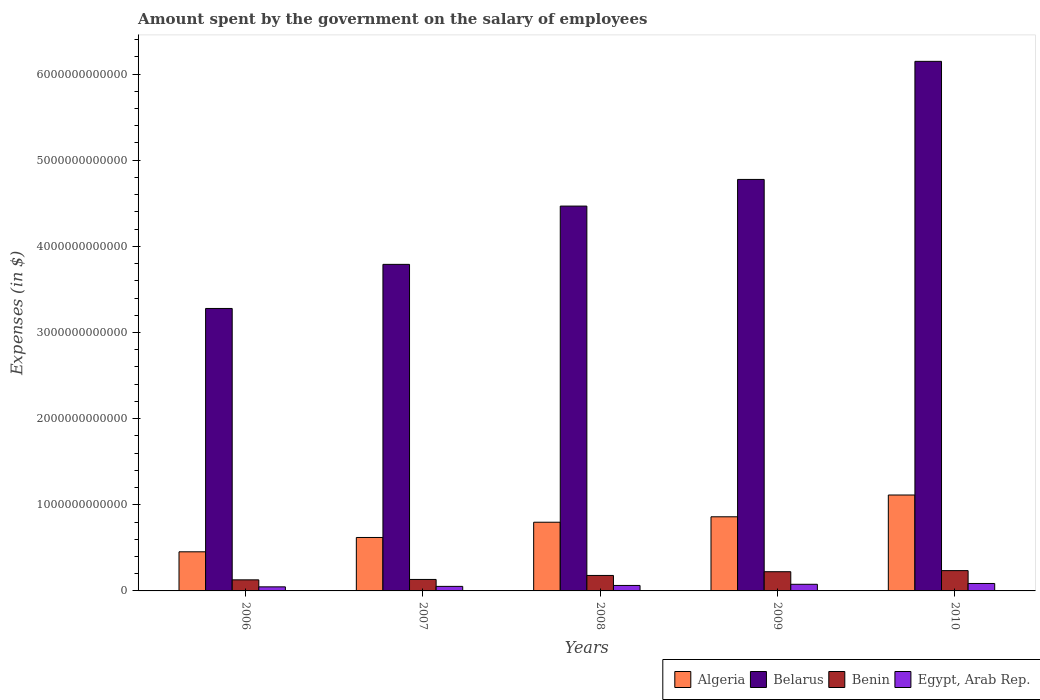How many different coloured bars are there?
Offer a very short reply. 4. How many groups of bars are there?
Keep it short and to the point. 5. Are the number of bars on each tick of the X-axis equal?
Your answer should be compact. Yes. How many bars are there on the 1st tick from the left?
Offer a very short reply. 4. What is the label of the 3rd group of bars from the left?
Provide a short and direct response. 2008. What is the amount spent on the salary of employees by the government in Egypt, Arab Rep. in 2009?
Make the answer very short. 7.70e+1. Across all years, what is the maximum amount spent on the salary of employees by the government in Egypt, Arab Rep.?
Your answer should be very brief. 8.64e+1. Across all years, what is the minimum amount spent on the salary of employees by the government in Egypt, Arab Rep.?
Provide a succinct answer. 4.73e+1. In which year was the amount spent on the salary of employees by the government in Algeria minimum?
Ensure brevity in your answer.  2006. What is the total amount spent on the salary of employees by the government in Egypt, Arab Rep. in the graph?
Give a very brief answer. 3.27e+11. What is the difference between the amount spent on the salary of employees by the government in Belarus in 2007 and that in 2009?
Your answer should be very brief. -9.86e+11. What is the difference between the amount spent on the salary of employees by the government in Egypt, Arab Rep. in 2009 and the amount spent on the salary of employees by the government in Benin in 2006?
Your answer should be very brief. -5.15e+1. What is the average amount spent on the salary of employees by the government in Algeria per year?
Make the answer very short. 7.69e+11. In the year 2006, what is the difference between the amount spent on the salary of employees by the government in Benin and amount spent on the salary of employees by the government in Belarus?
Keep it short and to the point. -3.15e+12. What is the ratio of the amount spent on the salary of employees by the government in Benin in 2008 to that in 2009?
Make the answer very short. 0.81. Is the difference between the amount spent on the salary of employees by the government in Benin in 2007 and 2009 greater than the difference between the amount spent on the salary of employees by the government in Belarus in 2007 and 2009?
Give a very brief answer. Yes. What is the difference between the highest and the second highest amount spent on the salary of employees by the government in Belarus?
Your answer should be very brief. 1.37e+12. What is the difference between the highest and the lowest amount spent on the salary of employees by the government in Algeria?
Your answer should be compact. 6.59e+11. Is it the case that in every year, the sum of the amount spent on the salary of employees by the government in Egypt, Arab Rep. and amount spent on the salary of employees by the government in Algeria is greater than the sum of amount spent on the salary of employees by the government in Benin and amount spent on the salary of employees by the government in Belarus?
Ensure brevity in your answer.  No. What does the 2nd bar from the left in 2008 represents?
Keep it short and to the point. Belarus. What does the 1st bar from the right in 2006 represents?
Offer a terse response. Egypt, Arab Rep. How many bars are there?
Offer a very short reply. 20. Are all the bars in the graph horizontal?
Your answer should be compact. No. What is the difference between two consecutive major ticks on the Y-axis?
Ensure brevity in your answer.  1.00e+12. Are the values on the major ticks of Y-axis written in scientific E-notation?
Offer a terse response. No. What is the title of the graph?
Make the answer very short. Amount spent by the government on the salary of employees. Does "Luxembourg" appear as one of the legend labels in the graph?
Your answer should be compact. No. What is the label or title of the Y-axis?
Give a very brief answer. Expenses (in $). What is the Expenses (in $) in Algeria in 2006?
Your answer should be compact. 4.54e+11. What is the Expenses (in $) in Belarus in 2006?
Keep it short and to the point. 3.28e+12. What is the Expenses (in $) of Benin in 2006?
Provide a succinct answer. 1.28e+11. What is the Expenses (in $) in Egypt, Arab Rep. in 2006?
Your answer should be compact. 4.73e+1. What is the Expenses (in $) in Algeria in 2007?
Make the answer very short. 6.20e+11. What is the Expenses (in $) of Belarus in 2007?
Your answer should be very brief. 3.79e+12. What is the Expenses (in $) of Benin in 2007?
Offer a terse response. 1.33e+11. What is the Expenses (in $) of Egypt, Arab Rep. in 2007?
Make the answer very short. 5.27e+1. What is the Expenses (in $) in Algeria in 2008?
Your answer should be very brief. 7.97e+11. What is the Expenses (in $) of Belarus in 2008?
Ensure brevity in your answer.  4.47e+12. What is the Expenses (in $) of Benin in 2008?
Ensure brevity in your answer.  1.80e+11. What is the Expenses (in $) in Egypt, Arab Rep. in 2008?
Ensure brevity in your answer.  6.35e+1. What is the Expenses (in $) in Algeria in 2009?
Offer a terse response. 8.61e+11. What is the Expenses (in $) of Belarus in 2009?
Provide a succinct answer. 4.78e+12. What is the Expenses (in $) in Benin in 2009?
Your answer should be very brief. 2.23e+11. What is the Expenses (in $) in Egypt, Arab Rep. in 2009?
Keep it short and to the point. 7.70e+1. What is the Expenses (in $) in Algeria in 2010?
Give a very brief answer. 1.11e+12. What is the Expenses (in $) in Belarus in 2010?
Keep it short and to the point. 6.15e+12. What is the Expenses (in $) in Benin in 2010?
Make the answer very short. 2.36e+11. What is the Expenses (in $) in Egypt, Arab Rep. in 2010?
Offer a terse response. 8.64e+1. Across all years, what is the maximum Expenses (in $) in Algeria?
Make the answer very short. 1.11e+12. Across all years, what is the maximum Expenses (in $) in Belarus?
Keep it short and to the point. 6.15e+12. Across all years, what is the maximum Expenses (in $) in Benin?
Your answer should be compact. 2.36e+11. Across all years, what is the maximum Expenses (in $) of Egypt, Arab Rep.?
Provide a short and direct response. 8.64e+1. Across all years, what is the minimum Expenses (in $) of Algeria?
Provide a succinct answer. 4.54e+11. Across all years, what is the minimum Expenses (in $) in Belarus?
Offer a terse response. 3.28e+12. Across all years, what is the minimum Expenses (in $) in Benin?
Make the answer very short. 1.28e+11. Across all years, what is the minimum Expenses (in $) in Egypt, Arab Rep.?
Make the answer very short. 4.73e+1. What is the total Expenses (in $) in Algeria in the graph?
Give a very brief answer. 3.85e+12. What is the total Expenses (in $) of Belarus in the graph?
Give a very brief answer. 2.25e+13. What is the total Expenses (in $) of Benin in the graph?
Offer a very short reply. 9.00e+11. What is the total Expenses (in $) of Egypt, Arab Rep. in the graph?
Your response must be concise. 3.27e+11. What is the difference between the Expenses (in $) in Algeria in 2006 and that in 2007?
Provide a succinct answer. -1.66e+11. What is the difference between the Expenses (in $) of Belarus in 2006 and that in 2007?
Your answer should be very brief. -5.12e+11. What is the difference between the Expenses (in $) of Benin in 2006 and that in 2007?
Give a very brief answer. -4.72e+09. What is the difference between the Expenses (in $) of Egypt, Arab Rep. in 2006 and that in 2007?
Provide a short and direct response. -5.49e+09. What is the difference between the Expenses (in $) of Algeria in 2006 and that in 2008?
Your response must be concise. -3.43e+11. What is the difference between the Expenses (in $) of Belarus in 2006 and that in 2008?
Make the answer very short. -1.19e+12. What is the difference between the Expenses (in $) in Benin in 2006 and that in 2008?
Keep it short and to the point. -5.12e+1. What is the difference between the Expenses (in $) of Egypt, Arab Rep. in 2006 and that in 2008?
Provide a short and direct response. -1.63e+1. What is the difference between the Expenses (in $) in Algeria in 2006 and that in 2009?
Offer a terse response. -4.06e+11. What is the difference between the Expenses (in $) in Belarus in 2006 and that in 2009?
Offer a terse response. -1.50e+12. What is the difference between the Expenses (in $) of Benin in 2006 and that in 2009?
Provide a succinct answer. -9.44e+1. What is the difference between the Expenses (in $) in Egypt, Arab Rep. in 2006 and that in 2009?
Your response must be concise. -2.97e+1. What is the difference between the Expenses (in $) in Algeria in 2006 and that in 2010?
Ensure brevity in your answer.  -6.59e+11. What is the difference between the Expenses (in $) in Belarus in 2006 and that in 2010?
Offer a very short reply. -2.87e+12. What is the difference between the Expenses (in $) of Benin in 2006 and that in 2010?
Keep it short and to the point. -1.07e+11. What is the difference between the Expenses (in $) in Egypt, Arab Rep. in 2006 and that in 2010?
Your answer should be very brief. -3.91e+1. What is the difference between the Expenses (in $) in Algeria in 2007 and that in 2008?
Ensure brevity in your answer.  -1.77e+11. What is the difference between the Expenses (in $) of Belarus in 2007 and that in 2008?
Offer a terse response. -6.76e+11. What is the difference between the Expenses (in $) in Benin in 2007 and that in 2008?
Provide a short and direct response. -4.65e+1. What is the difference between the Expenses (in $) of Egypt, Arab Rep. in 2007 and that in 2008?
Offer a terse response. -1.08e+1. What is the difference between the Expenses (in $) in Algeria in 2007 and that in 2009?
Keep it short and to the point. -2.40e+11. What is the difference between the Expenses (in $) in Belarus in 2007 and that in 2009?
Give a very brief answer. -9.86e+11. What is the difference between the Expenses (in $) of Benin in 2007 and that in 2009?
Keep it short and to the point. -8.97e+1. What is the difference between the Expenses (in $) of Egypt, Arab Rep. in 2007 and that in 2009?
Ensure brevity in your answer.  -2.42e+1. What is the difference between the Expenses (in $) of Algeria in 2007 and that in 2010?
Provide a short and direct response. -4.93e+11. What is the difference between the Expenses (in $) in Belarus in 2007 and that in 2010?
Keep it short and to the point. -2.36e+12. What is the difference between the Expenses (in $) of Benin in 2007 and that in 2010?
Your response must be concise. -1.02e+11. What is the difference between the Expenses (in $) in Egypt, Arab Rep. in 2007 and that in 2010?
Your answer should be compact. -3.36e+1. What is the difference between the Expenses (in $) in Algeria in 2008 and that in 2009?
Offer a terse response. -6.32e+1. What is the difference between the Expenses (in $) in Belarus in 2008 and that in 2009?
Provide a succinct answer. -3.10e+11. What is the difference between the Expenses (in $) in Benin in 2008 and that in 2009?
Your response must be concise. -4.32e+1. What is the difference between the Expenses (in $) in Egypt, Arab Rep. in 2008 and that in 2009?
Provide a short and direct response. -1.34e+1. What is the difference between the Expenses (in $) of Algeria in 2008 and that in 2010?
Offer a terse response. -3.16e+11. What is the difference between the Expenses (in $) in Belarus in 2008 and that in 2010?
Provide a short and direct response. -1.68e+12. What is the difference between the Expenses (in $) of Benin in 2008 and that in 2010?
Your response must be concise. -5.59e+1. What is the difference between the Expenses (in $) of Egypt, Arab Rep. in 2008 and that in 2010?
Provide a succinct answer. -2.28e+1. What is the difference between the Expenses (in $) of Algeria in 2009 and that in 2010?
Keep it short and to the point. -2.53e+11. What is the difference between the Expenses (in $) of Belarus in 2009 and that in 2010?
Make the answer very short. -1.37e+12. What is the difference between the Expenses (in $) in Benin in 2009 and that in 2010?
Make the answer very short. -1.27e+1. What is the difference between the Expenses (in $) in Egypt, Arab Rep. in 2009 and that in 2010?
Offer a very short reply. -9.41e+09. What is the difference between the Expenses (in $) of Algeria in 2006 and the Expenses (in $) of Belarus in 2007?
Your response must be concise. -3.34e+12. What is the difference between the Expenses (in $) in Algeria in 2006 and the Expenses (in $) in Benin in 2007?
Provide a succinct answer. 3.21e+11. What is the difference between the Expenses (in $) of Algeria in 2006 and the Expenses (in $) of Egypt, Arab Rep. in 2007?
Keep it short and to the point. 4.01e+11. What is the difference between the Expenses (in $) in Belarus in 2006 and the Expenses (in $) in Benin in 2007?
Offer a very short reply. 3.15e+12. What is the difference between the Expenses (in $) of Belarus in 2006 and the Expenses (in $) of Egypt, Arab Rep. in 2007?
Ensure brevity in your answer.  3.23e+12. What is the difference between the Expenses (in $) of Benin in 2006 and the Expenses (in $) of Egypt, Arab Rep. in 2007?
Give a very brief answer. 7.57e+1. What is the difference between the Expenses (in $) in Algeria in 2006 and the Expenses (in $) in Belarus in 2008?
Keep it short and to the point. -4.01e+12. What is the difference between the Expenses (in $) of Algeria in 2006 and the Expenses (in $) of Benin in 2008?
Your answer should be very brief. 2.74e+11. What is the difference between the Expenses (in $) of Algeria in 2006 and the Expenses (in $) of Egypt, Arab Rep. in 2008?
Provide a short and direct response. 3.91e+11. What is the difference between the Expenses (in $) of Belarus in 2006 and the Expenses (in $) of Benin in 2008?
Your answer should be very brief. 3.10e+12. What is the difference between the Expenses (in $) of Belarus in 2006 and the Expenses (in $) of Egypt, Arab Rep. in 2008?
Make the answer very short. 3.22e+12. What is the difference between the Expenses (in $) in Benin in 2006 and the Expenses (in $) in Egypt, Arab Rep. in 2008?
Offer a terse response. 6.49e+1. What is the difference between the Expenses (in $) in Algeria in 2006 and the Expenses (in $) in Belarus in 2009?
Keep it short and to the point. -4.32e+12. What is the difference between the Expenses (in $) in Algeria in 2006 and the Expenses (in $) in Benin in 2009?
Offer a terse response. 2.31e+11. What is the difference between the Expenses (in $) of Algeria in 2006 and the Expenses (in $) of Egypt, Arab Rep. in 2009?
Provide a short and direct response. 3.77e+11. What is the difference between the Expenses (in $) in Belarus in 2006 and the Expenses (in $) in Benin in 2009?
Your answer should be very brief. 3.06e+12. What is the difference between the Expenses (in $) in Belarus in 2006 and the Expenses (in $) in Egypt, Arab Rep. in 2009?
Provide a succinct answer. 3.20e+12. What is the difference between the Expenses (in $) in Benin in 2006 and the Expenses (in $) in Egypt, Arab Rep. in 2009?
Provide a short and direct response. 5.15e+1. What is the difference between the Expenses (in $) in Algeria in 2006 and the Expenses (in $) in Belarus in 2010?
Make the answer very short. -5.69e+12. What is the difference between the Expenses (in $) in Algeria in 2006 and the Expenses (in $) in Benin in 2010?
Your answer should be compact. 2.18e+11. What is the difference between the Expenses (in $) in Algeria in 2006 and the Expenses (in $) in Egypt, Arab Rep. in 2010?
Keep it short and to the point. 3.68e+11. What is the difference between the Expenses (in $) of Belarus in 2006 and the Expenses (in $) of Benin in 2010?
Offer a very short reply. 3.04e+12. What is the difference between the Expenses (in $) in Belarus in 2006 and the Expenses (in $) in Egypt, Arab Rep. in 2010?
Your response must be concise. 3.19e+12. What is the difference between the Expenses (in $) in Benin in 2006 and the Expenses (in $) in Egypt, Arab Rep. in 2010?
Offer a very short reply. 4.21e+1. What is the difference between the Expenses (in $) in Algeria in 2007 and the Expenses (in $) in Belarus in 2008?
Make the answer very short. -3.85e+12. What is the difference between the Expenses (in $) in Algeria in 2007 and the Expenses (in $) in Benin in 2008?
Keep it short and to the point. 4.41e+11. What is the difference between the Expenses (in $) of Algeria in 2007 and the Expenses (in $) of Egypt, Arab Rep. in 2008?
Provide a short and direct response. 5.57e+11. What is the difference between the Expenses (in $) of Belarus in 2007 and the Expenses (in $) of Benin in 2008?
Offer a very short reply. 3.61e+12. What is the difference between the Expenses (in $) of Belarus in 2007 and the Expenses (in $) of Egypt, Arab Rep. in 2008?
Your answer should be compact. 3.73e+12. What is the difference between the Expenses (in $) in Benin in 2007 and the Expenses (in $) in Egypt, Arab Rep. in 2008?
Keep it short and to the point. 6.97e+1. What is the difference between the Expenses (in $) in Algeria in 2007 and the Expenses (in $) in Belarus in 2009?
Offer a terse response. -4.16e+12. What is the difference between the Expenses (in $) in Algeria in 2007 and the Expenses (in $) in Benin in 2009?
Your answer should be compact. 3.97e+11. What is the difference between the Expenses (in $) of Algeria in 2007 and the Expenses (in $) of Egypt, Arab Rep. in 2009?
Make the answer very short. 5.43e+11. What is the difference between the Expenses (in $) in Belarus in 2007 and the Expenses (in $) in Benin in 2009?
Your response must be concise. 3.57e+12. What is the difference between the Expenses (in $) of Belarus in 2007 and the Expenses (in $) of Egypt, Arab Rep. in 2009?
Ensure brevity in your answer.  3.71e+12. What is the difference between the Expenses (in $) in Benin in 2007 and the Expenses (in $) in Egypt, Arab Rep. in 2009?
Keep it short and to the point. 5.62e+1. What is the difference between the Expenses (in $) in Algeria in 2007 and the Expenses (in $) in Belarus in 2010?
Provide a succinct answer. -5.53e+12. What is the difference between the Expenses (in $) in Algeria in 2007 and the Expenses (in $) in Benin in 2010?
Make the answer very short. 3.85e+11. What is the difference between the Expenses (in $) of Algeria in 2007 and the Expenses (in $) of Egypt, Arab Rep. in 2010?
Provide a succinct answer. 5.34e+11. What is the difference between the Expenses (in $) in Belarus in 2007 and the Expenses (in $) in Benin in 2010?
Your answer should be very brief. 3.55e+12. What is the difference between the Expenses (in $) of Belarus in 2007 and the Expenses (in $) of Egypt, Arab Rep. in 2010?
Provide a short and direct response. 3.70e+12. What is the difference between the Expenses (in $) of Benin in 2007 and the Expenses (in $) of Egypt, Arab Rep. in 2010?
Offer a terse response. 4.68e+1. What is the difference between the Expenses (in $) in Algeria in 2008 and the Expenses (in $) in Belarus in 2009?
Make the answer very short. -3.98e+12. What is the difference between the Expenses (in $) in Algeria in 2008 and the Expenses (in $) in Benin in 2009?
Make the answer very short. 5.74e+11. What is the difference between the Expenses (in $) of Algeria in 2008 and the Expenses (in $) of Egypt, Arab Rep. in 2009?
Make the answer very short. 7.20e+11. What is the difference between the Expenses (in $) of Belarus in 2008 and the Expenses (in $) of Benin in 2009?
Your response must be concise. 4.24e+12. What is the difference between the Expenses (in $) of Belarus in 2008 and the Expenses (in $) of Egypt, Arab Rep. in 2009?
Ensure brevity in your answer.  4.39e+12. What is the difference between the Expenses (in $) of Benin in 2008 and the Expenses (in $) of Egypt, Arab Rep. in 2009?
Your response must be concise. 1.03e+11. What is the difference between the Expenses (in $) of Algeria in 2008 and the Expenses (in $) of Belarus in 2010?
Your answer should be very brief. -5.35e+12. What is the difference between the Expenses (in $) in Algeria in 2008 and the Expenses (in $) in Benin in 2010?
Offer a terse response. 5.62e+11. What is the difference between the Expenses (in $) in Algeria in 2008 and the Expenses (in $) in Egypt, Arab Rep. in 2010?
Ensure brevity in your answer.  7.11e+11. What is the difference between the Expenses (in $) of Belarus in 2008 and the Expenses (in $) of Benin in 2010?
Your answer should be compact. 4.23e+12. What is the difference between the Expenses (in $) of Belarus in 2008 and the Expenses (in $) of Egypt, Arab Rep. in 2010?
Make the answer very short. 4.38e+12. What is the difference between the Expenses (in $) of Benin in 2008 and the Expenses (in $) of Egypt, Arab Rep. in 2010?
Offer a terse response. 9.33e+1. What is the difference between the Expenses (in $) of Algeria in 2009 and the Expenses (in $) of Belarus in 2010?
Make the answer very short. -5.29e+12. What is the difference between the Expenses (in $) in Algeria in 2009 and the Expenses (in $) in Benin in 2010?
Offer a terse response. 6.25e+11. What is the difference between the Expenses (in $) of Algeria in 2009 and the Expenses (in $) of Egypt, Arab Rep. in 2010?
Offer a very short reply. 7.74e+11. What is the difference between the Expenses (in $) in Belarus in 2009 and the Expenses (in $) in Benin in 2010?
Your response must be concise. 4.54e+12. What is the difference between the Expenses (in $) of Belarus in 2009 and the Expenses (in $) of Egypt, Arab Rep. in 2010?
Provide a short and direct response. 4.69e+12. What is the difference between the Expenses (in $) of Benin in 2009 and the Expenses (in $) of Egypt, Arab Rep. in 2010?
Offer a terse response. 1.37e+11. What is the average Expenses (in $) in Algeria per year?
Your response must be concise. 7.69e+11. What is the average Expenses (in $) of Belarus per year?
Offer a terse response. 4.49e+12. What is the average Expenses (in $) of Benin per year?
Offer a terse response. 1.80e+11. What is the average Expenses (in $) of Egypt, Arab Rep. per year?
Keep it short and to the point. 6.54e+1. In the year 2006, what is the difference between the Expenses (in $) in Algeria and Expenses (in $) in Belarus?
Give a very brief answer. -2.82e+12. In the year 2006, what is the difference between the Expenses (in $) of Algeria and Expenses (in $) of Benin?
Make the answer very short. 3.26e+11. In the year 2006, what is the difference between the Expenses (in $) in Algeria and Expenses (in $) in Egypt, Arab Rep.?
Your answer should be very brief. 4.07e+11. In the year 2006, what is the difference between the Expenses (in $) in Belarus and Expenses (in $) in Benin?
Give a very brief answer. 3.15e+12. In the year 2006, what is the difference between the Expenses (in $) of Belarus and Expenses (in $) of Egypt, Arab Rep.?
Ensure brevity in your answer.  3.23e+12. In the year 2006, what is the difference between the Expenses (in $) in Benin and Expenses (in $) in Egypt, Arab Rep.?
Your response must be concise. 8.12e+1. In the year 2007, what is the difference between the Expenses (in $) of Algeria and Expenses (in $) of Belarus?
Ensure brevity in your answer.  -3.17e+12. In the year 2007, what is the difference between the Expenses (in $) of Algeria and Expenses (in $) of Benin?
Ensure brevity in your answer.  4.87e+11. In the year 2007, what is the difference between the Expenses (in $) of Algeria and Expenses (in $) of Egypt, Arab Rep.?
Provide a short and direct response. 5.68e+11. In the year 2007, what is the difference between the Expenses (in $) in Belarus and Expenses (in $) in Benin?
Make the answer very short. 3.66e+12. In the year 2007, what is the difference between the Expenses (in $) in Belarus and Expenses (in $) in Egypt, Arab Rep.?
Offer a terse response. 3.74e+12. In the year 2007, what is the difference between the Expenses (in $) in Benin and Expenses (in $) in Egypt, Arab Rep.?
Keep it short and to the point. 8.04e+1. In the year 2008, what is the difference between the Expenses (in $) in Algeria and Expenses (in $) in Belarus?
Your answer should be compact. -3.67e+12. In the year 2008, what is the difference between the Expenses (in $) of Algeria and Expenses (in $) of Benin?
Your response must be concise. 6.18e+11. In the year 2008, what is the difference between the Expenses (in $) of Algeria and Expenses (in $) of Egypt, Arab Rep.?
Offer a very short reply. 7.34e+11. In the year 2008, what is the difference between the Expenses (in $) in Belarus and Expenses (in $) in Benin?
Make the answer very short. 4.29e+12. In the year 2008, what is the difference between the Expenses (in $) in Belarus and Expenses (in $) in Egypt, Arab Rep.?
Give a very brief answer. 4.40e+12. In the year 2008, what is the difference between the Expenses (in $) in Benin and Expenses (in $) in Egypt, Arab Rep.?
Ensure brevity in your answer.  1.16e+11. In the year 2009, what is the difference between the Expenses (in $) in Algeria and Expenses (in $) in Belarus?
Your answer should be very brief. -3.92e+12. In the year 2009, what is the difference between the Expenses (in $) of Algeria and Expenses (in $) of Benin?
Your answer should be very brief. 6.38e+11. In the year 2009, what is the difference between the Expenses (in $) of Algeria and Expenses (in $) of Egypt, Arab Rep.?
Give a very brief answer. 7.84e+11. In the year 2009, what is the difference between the Expenses (in $) of Belarus and Expenses (in $) of Benin?
Offer a terse response. 4.55e+12. In the year 2009, what is the difference between the Expenses (in $) in Belarus and Expenses (in $) in Egypt, Arab Rep.?
Make the answer very short. 4.70e+12. In the year 2009, what is the difference between the Expenses (in $) in Benin and Expenses (in $) in Egypt, Arab Rep.?
Offer a very short reply. 1.46e+11. In the year 2010, what is the difference between the Expenses (in $) in Algeria and Expenses (in $) in Belarus?
Offer a very short reply. -5.03e+12. In the year 2010, what is the difference between the Expenses (in $) in Algeria and Expenses (in $) in Benin?
Give a very brief answer. 8.78e+11. In the year 2010, what is the difference between the Expenses (in $) in Algeria and Expenses (in $) in Egypt, Arab Rep.?
Your response must be concise. 1.03e+12. In the year 2010, what is the difference between the Expenses (in $) in Belarus and Expenses (in $) in Benin?
Ensure brevity in your answer.  5.91e+12. In the year 2010, what is the difference between the Expenses (in $) of Belarus and Expenses (in $) of Egypt, Arab Rep.?
Provide a short and direct response. 6.06e+12. In the year 2010, what is the difference between the Expenses (in $) of Benin and Expenses (in $) of Egypt, Arab Rep.?
Provide a short and direct response. 1.49e+11. What is the ratio of the Expenses (in $) in Algeria in 2006 to that in 2007?
Offer a very short reply. 0.73. What is the ratio of the Expenses (in $) of Belarus in 2006 to that in 2007?
Provide a short and direct response. 0.86. What is the ratio of the Expenses (in $) of Benin in 2006 to that in 2007?
Provide a short and direct response. 0.96. What is the ratio of the Expenses (in $) in Egypt, Arab Rep. in 2006 to that in 2007?
Offer a very short reply. 0.9. What is the ratio of the Expenses (in $) of Algeria in 2006 to that in 2008?
Give a very brief answer. 0.57. What is the ratio of the Expenses (in $) in Belarus in 2006 to that in 2008?
Ensure brevity in your answer.  0.73. What is the ratio of the Expenses (in $) in Benin in 2006 to that in 2008?
Offer a very short reply. 0.71. What is the ratio of the Expenses (in $) of Egypt, Arab Rep. in 2006 to that in 2008?
Keep it short and to the point. 0.74. What is the ratio of the Expenses (in $) of Algeria in 2006 to that in 2009?
Offer a terse response. 0.53. What is the ratio of the Expenses (in $) in Belarus in 2006 to that in 2009?
Your answer should be compact. 0.69. What is the ratio of the Expenses (in $) in Benin in 2006 to that in 2009?
Offer a very short reply. 0.58. What is the ratio of the Expenses (in $) in Egypt, Arab Rep. in 2006 to that in 2009?
Your response must be concise. 0.61. What is the ratio of the Expenses (in $) of Algeria in 2006 to that in 2010?
Ensure brevity in your answer.  0.41. What is the ratio of the Expenses (in $) of Belarus in 2006 to that in 2010?
Your response must be concise. 0.53. What is the ratio of the Expenses (in $) in Benin in 2006 to that in 2010?
Offer a very short reply. 0.55. What is the ratio of the Expenses (in $) in Egypt, Arab Rep. in 2006 to that in 2010?
Give a very brief answer. 0.55. What is the ratio of the Expenses (in $) of Algeria in 2007 to that in 2008?
Provide a succinct answer. 0.78. What is the ratio of the Expenses (in $) of Belarus in 2007 to that in 2008?
Your response must be concise. 0.85. What is the ratio of the Expenses (in $) of Benin in 2007 to that in 2008?
Ensure brevity in your answer.  0.74. What is the ratio of the Expenses (in $) of Egypt, Arab Rep. in 2007 to that in 2008?
Your answer should be very brief. 0.83. What is the ratio of the Expenses (in $) of Algeria in 2007 to that in 2009?
Provide a short and direct response. 0.72. What is the ratio of the Expenses (in $) in Belarus in 2007 to that in 2009?
Make the answer very short. 0.79. What is the ratio of the Expenses (in $) of Benin in 2007 to that in 2009?
Your answer should be very brief. 0.6. What is the ratio of the Expenses (in $) in Egypt, Arab Rep. in 2007 to that in 2009?
Provide a succinct answer. 0.69. What is the ratio of the Expenses (in $) in Algeria in 2007 to that in 2010?
Make the answer very short. 0.56. What is the ratio of the Expenses (in $) of Belarus in 2007 to that in 2010?
Offer a terse response. 0.62. What is the ratio of the Expenses (in $) of Benin in 2007 to that in 2010?
Offer a very short reply. 0.57. What is the ratio of the Expenses (in $) in Egypt, Arab Rep. in 2007 to that in 2010?
Offer a terse response. 0.61. What is the ratio of the Expenses (in $) of Algeria in 2008 to that in 2009?
Provide a succinct answer. 0.93. What is the ratio of the Expenses (in $) in Belarus in 2008 to that in 2009?
Give a very brief answer. 0.94. What is the ratio of the Expenses (in $) in Benin in 2008 to that in 2009?
Provide a succinct answer. 0.81. What is the ratio of the Expenses (in $) in Egypt, Arab Rep. in 2008 to that in 2009?
Make the answer very short. 0.83. What is the ratio of the Expenses (in $) of Algeria in 2008 to that in 2010?
Provide a succinct answer. 0.72. What is the ratio of the Expenses (in $) in Belarus in 2008 to that in 2010?
Provide a short and direct response. 0.73. What is the ratio of the Expenses (in $) of Benin in 2008 to that in 2010?
Give a very brief answer. 0.76. What is the ratio of the Expenses (in $) of Egypt, Arab Rep. in 2008 to that in 2010?
Your answer should be compact. 0.74. What is the ratio of the Expenses (in $) in Algeria in 2009 to that in 2010?
Your answer should be compact. 0.77. What is the ratio of the Expenses (in $) in Belarus in 2009 to that in 2010?
Your answer should be very brief. 0.78. What is the ratio of the Expenses (in $) in Benin in 2009 to that in 2010?
Provide a short and direct response. 0.95. What is the ratio of the Expenses (in $) in Egypt, Arab Rep. in 2009 to that in 2010?
Offer a very short reply. 0.89. What is the difference between the highest and the second highest Expenses (in $) in Algeria?
Ensure brevity in your answer.  2.53e+11. What is the difference between the highest and the second highest Expenses (in $) of Belarus?
Make the answer very short. 1.37e+12. What is the difference between the highest and the second highest Expenses (in $) in Benin?
Provide a short and direct response. 1.27e+1. What is the difference between the highest and the second highest Expenses (in $) of Egypt, Arab Rep.?
Make the answer very short. 9.41e+09. What is the difference between the highest and the lowest Expenses (in $) of Algeria?
Your answer should be compact. 6.59e+11. What is the difference between the highest and the lowest Expenses (in $) of Belarus?
Provide a short and direct response. 2.87e+12. What is the difference between the highest and the lowest Expenses (in $) in Benin?
Your answer should be compact. 1.07e+11. What is the difference between the highest and the lowest Expenses (in $) in Egypt, Arab Rep.?
Give a very brief answer. 3.91e+1. 